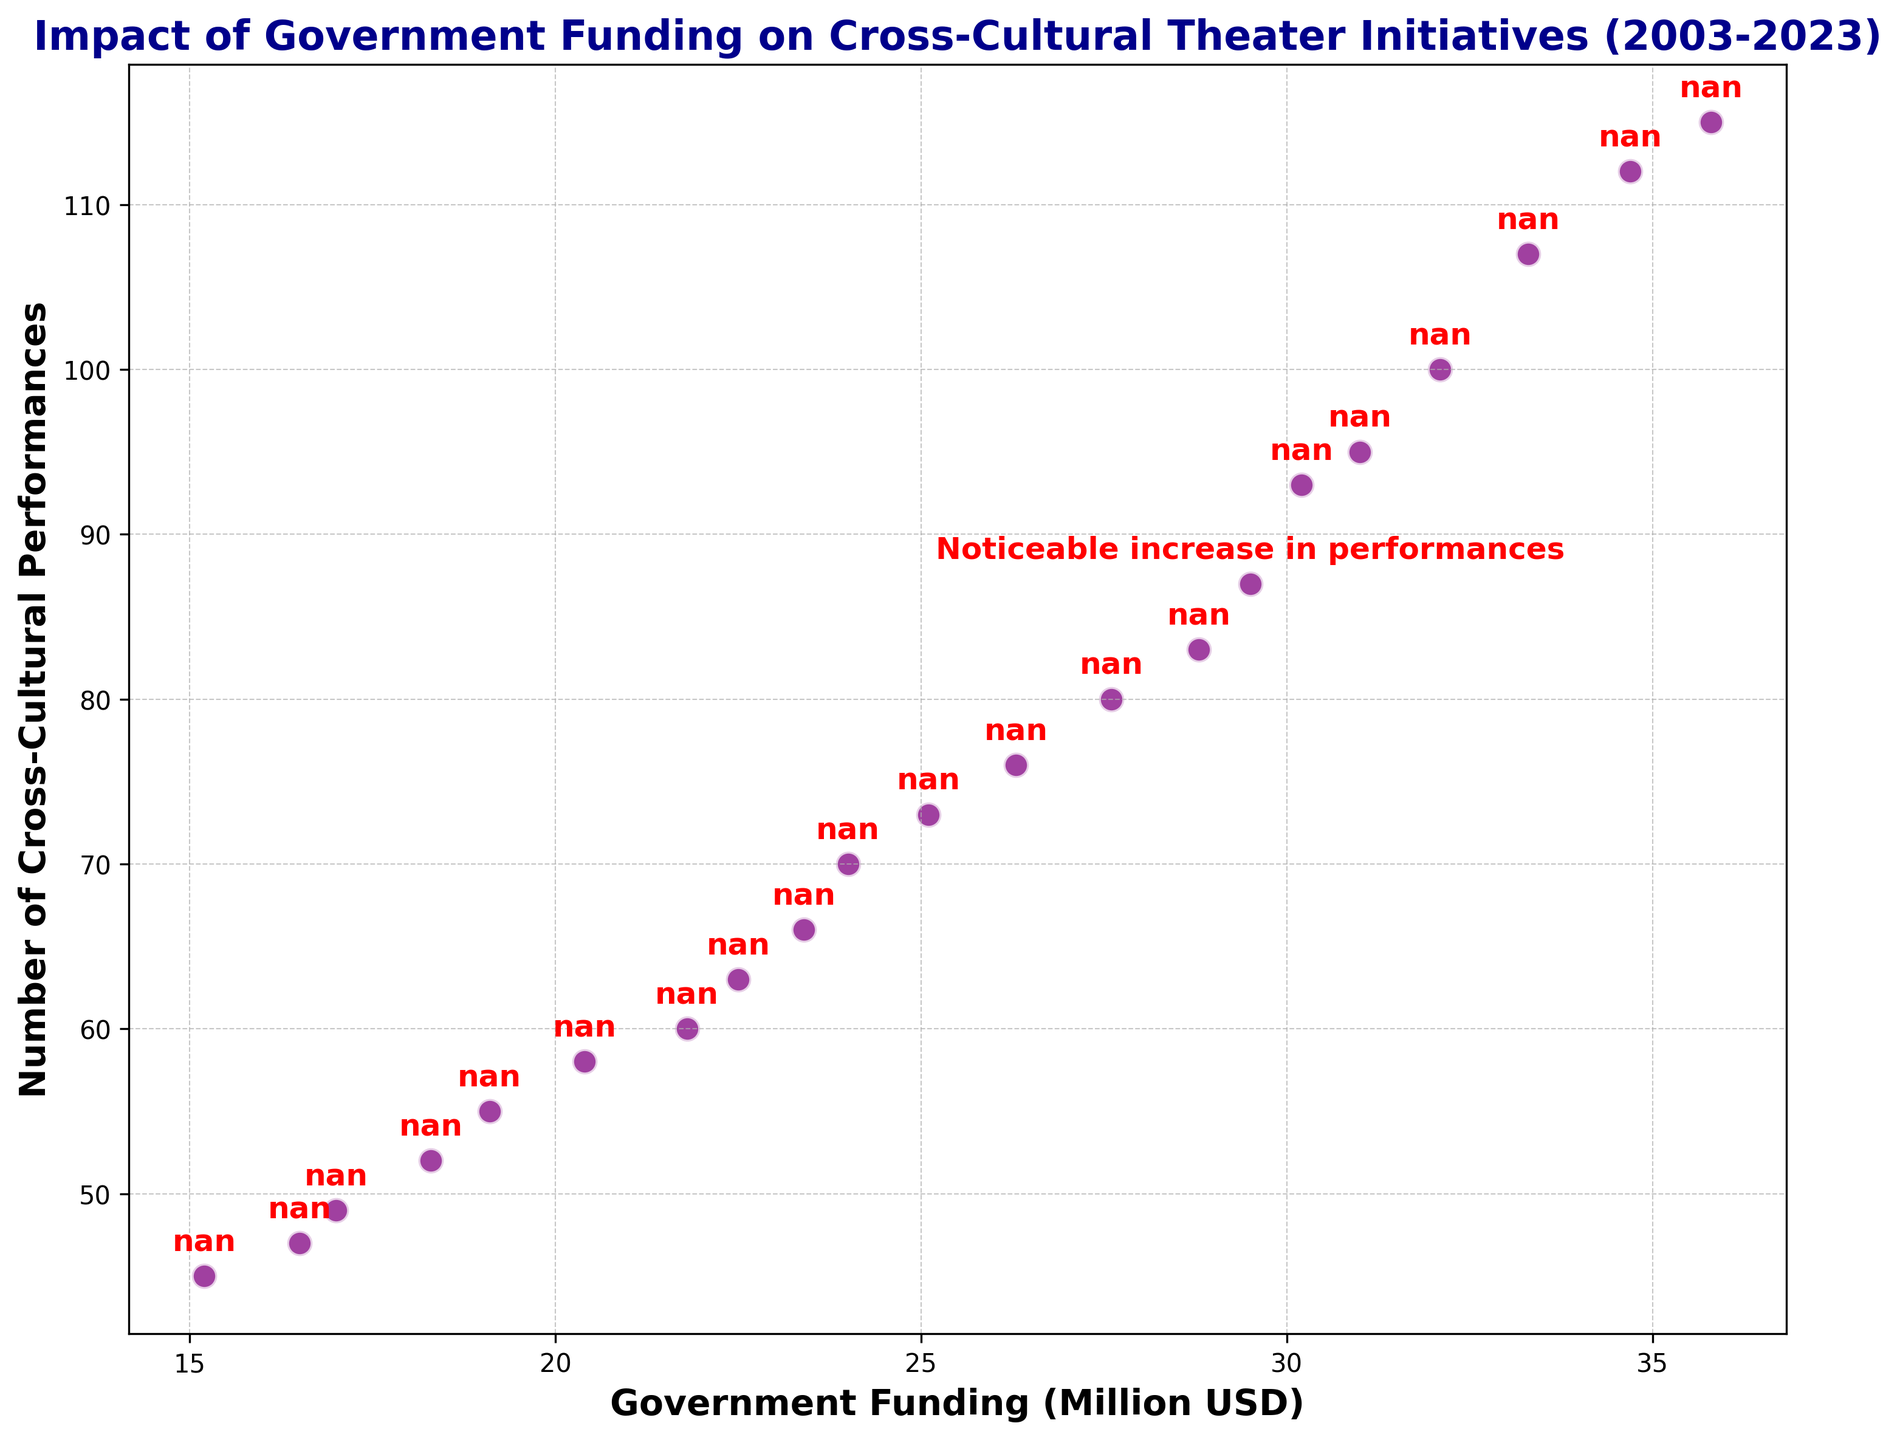What is the general trend observed in the relationship between government funding and the number of cross-cultural performances over the years? The scatter plot shows an increasing trend where the number of cross-cultural performances rises steadily with the increase in government funding, indicating a positive correlation.
Answer: Increasing trend How many cross-cultural performances were held in 2017, and how does it compare with 2016? In 2017, there were 87 cross-cultural performances. In 2016, there were 83 performances. By comparing these two values, we can see an increase in 2017.
Answer: 87 vs. 83 What does the text annotation mention, and where is it located on the plot? The text annotation mentions a "Noticeable increase in performances" and is located at the data point corresponding to the year 2017, around 29.5 million USD in government funding and 87 performances.
Answer: "Noticeable increase in performances" at 2017 Estimate the average increase in the number of cross-cultural performances for each additional million USD in government funding. By looking at intervals between key points, such as from 2003 to 2023, the total increase in performances is 70 (115 - 45) and the total increase in funding is 20.6 million USD (35.8 - 15.2). Dividing the total increase in performances by the total increase in funding gives us the average: 70 / 20.6 ≈ 3.40 performances per million USD.
Answer: Approximately 3.40 performances per million USD Which year shows the highest number of cross-cultural performances, and what was the government funding that year? The scatter plot shows that the highest number of cross-cultural performances was in 2023, with 115 performances. The government funding that year was 35.8 million USD.
Answer: 2023, 115 performances at 35.8 million USD How does the number of cross-cultural performances in 2020 compare to that in 2010? In 2020, there were 100 cross-cultural performances, while in 2010, there were 63 performances. This shows an increase of 37 performances over the decade.
Answer: 100 vs. 63 Identify the year with the smallest number of cross-cultural performances and specify the correlating government funding for that year. The year with the smallest number of cross-cultural performances is 2003, with 45 performances, and the corresponding government funding for that year was 15.2 million USD.
Answer: 2003, 45 performances at 15.2 million USD Calculate the total increase in government funding from 2003 to 2023. The government funding in 2003 was 15.2 million USD and in 2023 it was 35.8 million USD. The total increase is 35.8 - 15.2 = 20.6 million USD.
Answer: 20.6 million USD 